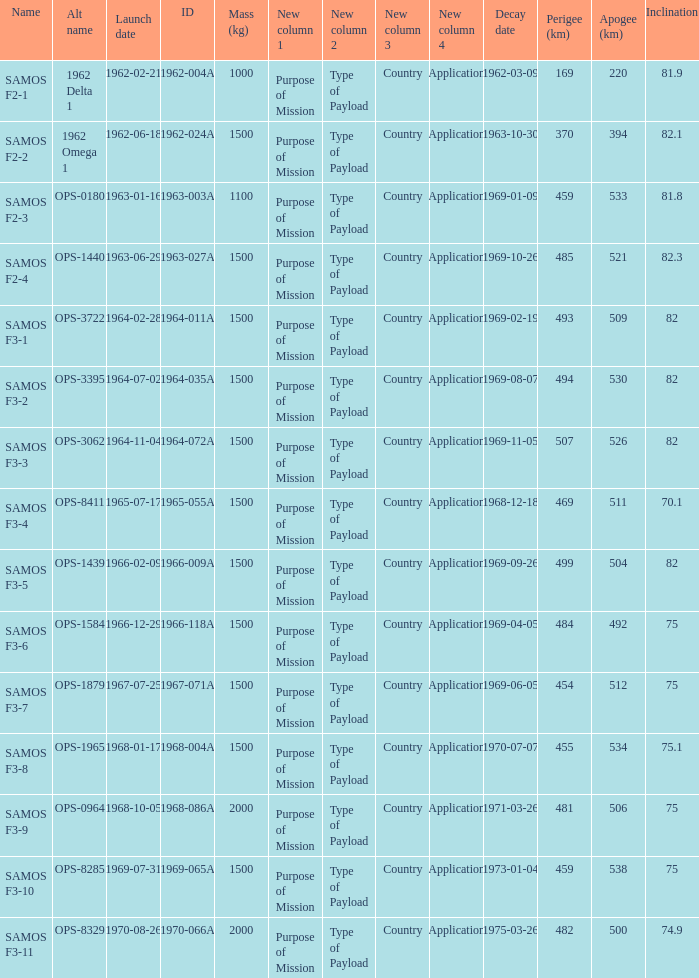What is the maximum apogee for samos f3-3? 526.0. 